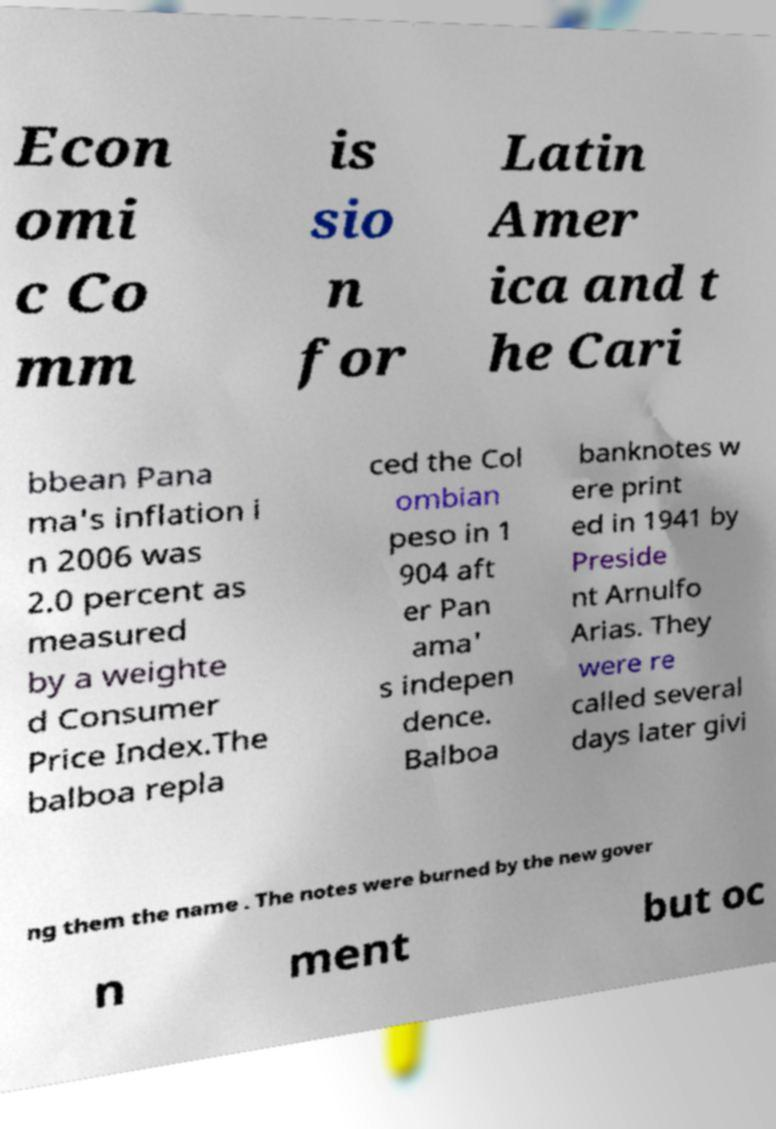Please read and relay the text visible in this image. What does it say? Econ omi c Co mm is sio n for Latin Amer ica and t he Cari bbean Pana ma's inflation i n 2006 was 2.0 percent as measured by a weighte d Consumer Price Index.The balboa repla ced the Col ombian peso in 1 904 aft er Pan ama' s indepen dence. Balboa banknotes w ere print ed in 1941 by Preside nt Arnulfo Arias. They were re called several days later givi ng them the name . The notes were burned by the new gover n ment but oc 